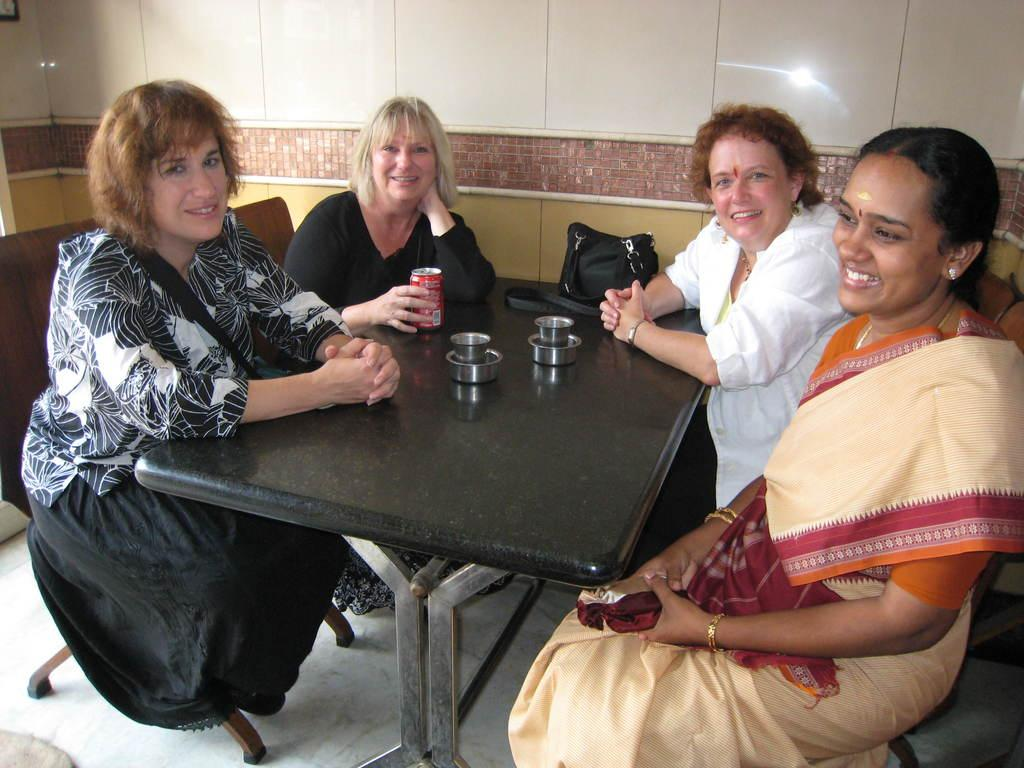How many women are present in the image? There are four women in the image. What are the women doing in the image? The women are sitting on chairs. What can be seen on the table in the image? There is a coke bottle, a steel cup, a steel glass, and a black handbag on the table. What type of square object can be seen on the table in the image? There is no square object present on the table in the image. 